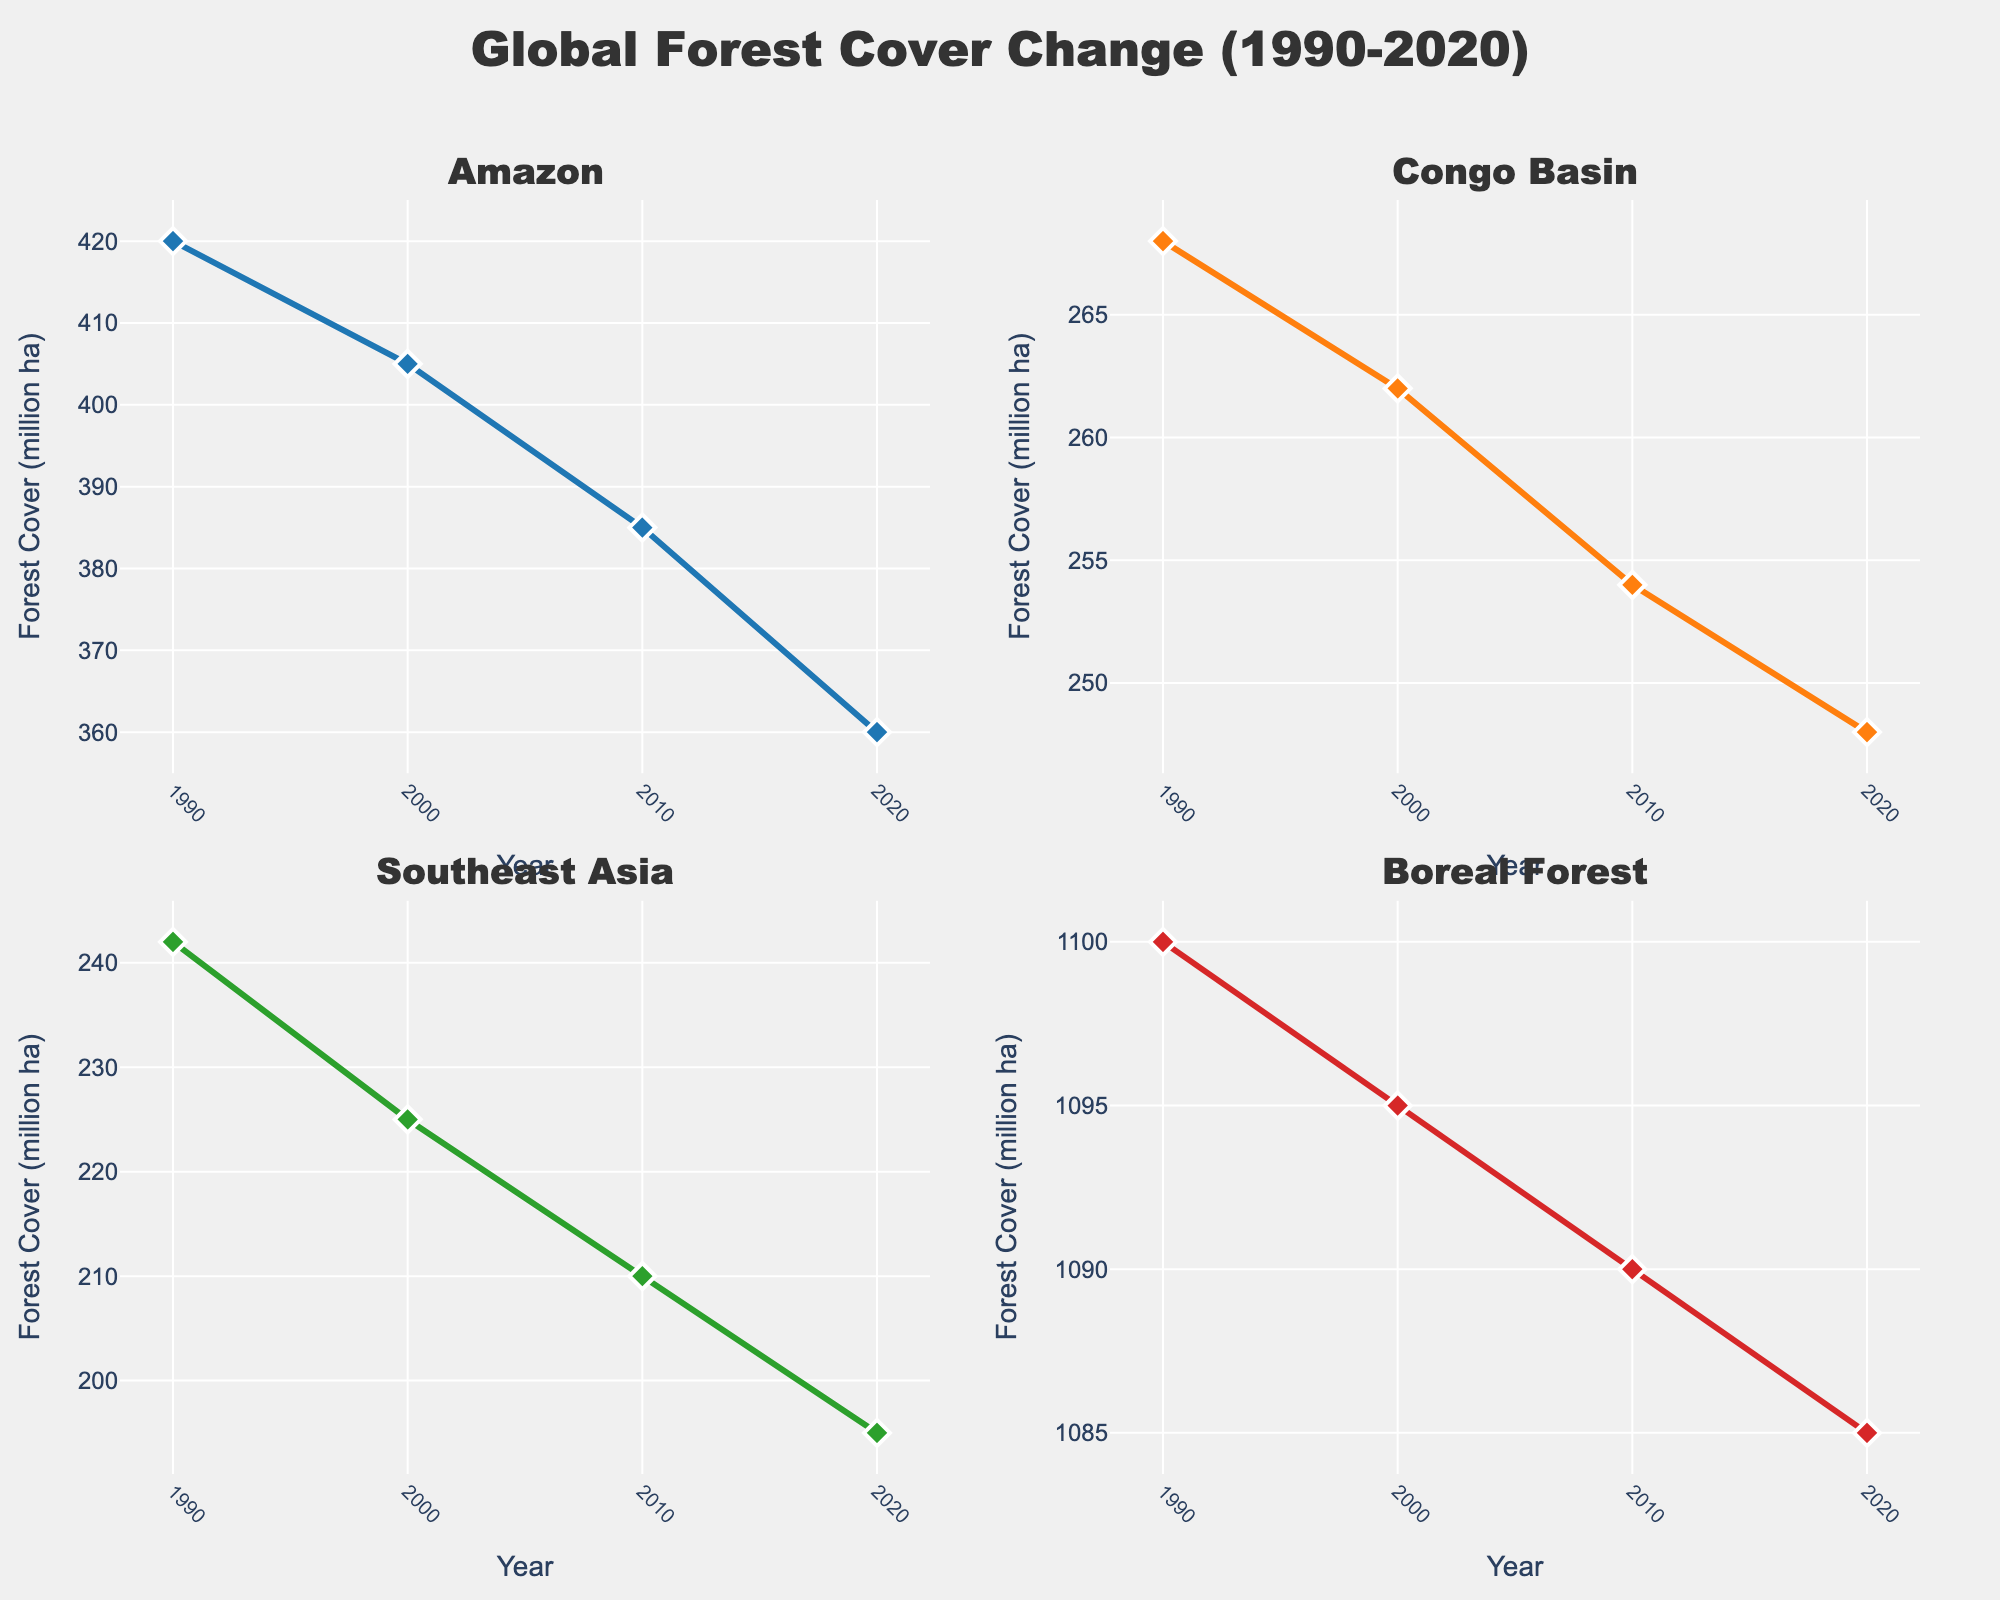What is the title of the figure? The title is displayed at the top center of the plot and reads "Global Forest Cover Change (1990-2020)".
Answer: Global Forest Cover Change (1990-2020) How many regions are compared in the figure? The figure consists of four subplots, each representing a different region.
Answer: Four Which region had the highest forest cover in 1990? By inspecting the y-axis values in each subplot for the year 1990, the Boreal Forest has the highest forest cover.
Answer: Boreal Forest How did the forest cover in the Amazon change from 1990 to 2020? In the Amazon subplot, the forest cover decreased from 420 million hectares in 1990 to 360 million hectares in 2020.
Answer: Decreased by 60 million hectares Which region saw the greatest decrease in forest cover between 1990 and 2020? Comparing the initial and final values in the subplots for each region, the Amazon saw the greatest decrease from 420 to 360 million hectares.
Answer: Amazon What was the forest cover in Southeast Asia in 2010? By looking at the Southeast Asia subplot at the 2010 marker, the forest cover was 210 million hectares.
Answer: 210 million hectares By how many million hectares did the Congo Basin's forest cover decrease from 1990 to 2020? The Congo Basin's forest cover decreased from 268 million hectares in 1990 to 248 million hectares in 2020, a decrease of 20 million hectares.
Answer: 20 million hectares Which region's forest cover remained relatively stable from 1990 to 2020? The Boreal Forest subplot shows a slight decline but remains relatively stable, moving from 1100 million hectares in 1990 to 1085 million hectares in 2020.
Answer: Boreal Forest How does the rate of forest cover change in Southeast Asia compare between 1990-2000 and 2000-2010? Between 1990 and 2000, the forest cover in Southeast Asia dropped from 242 to 225 million hectares (17 million hectares). From 2000 to 2010, it dropped from 225 to 210 million hectares (15 million hectares). Thus, the rate of decrease was slightly higher in the first period.
Answer: Higher in 1990-2000 Which region had the least forest cover in 2020? By checking the final data points in each subplot for the year 2020, Southeast Asia had the least forest cover with 195 million hectares.
Answer: Southeast Asia 